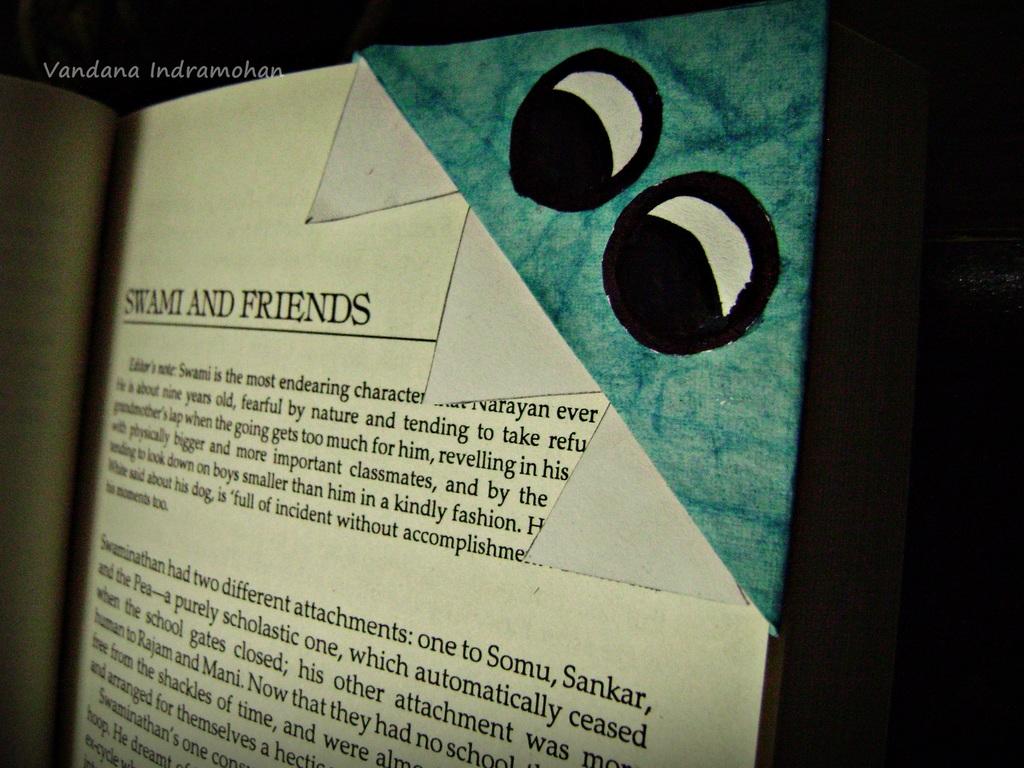What is written in bold font on the top of the page?
Give a very brief answer. Swami and friends. 